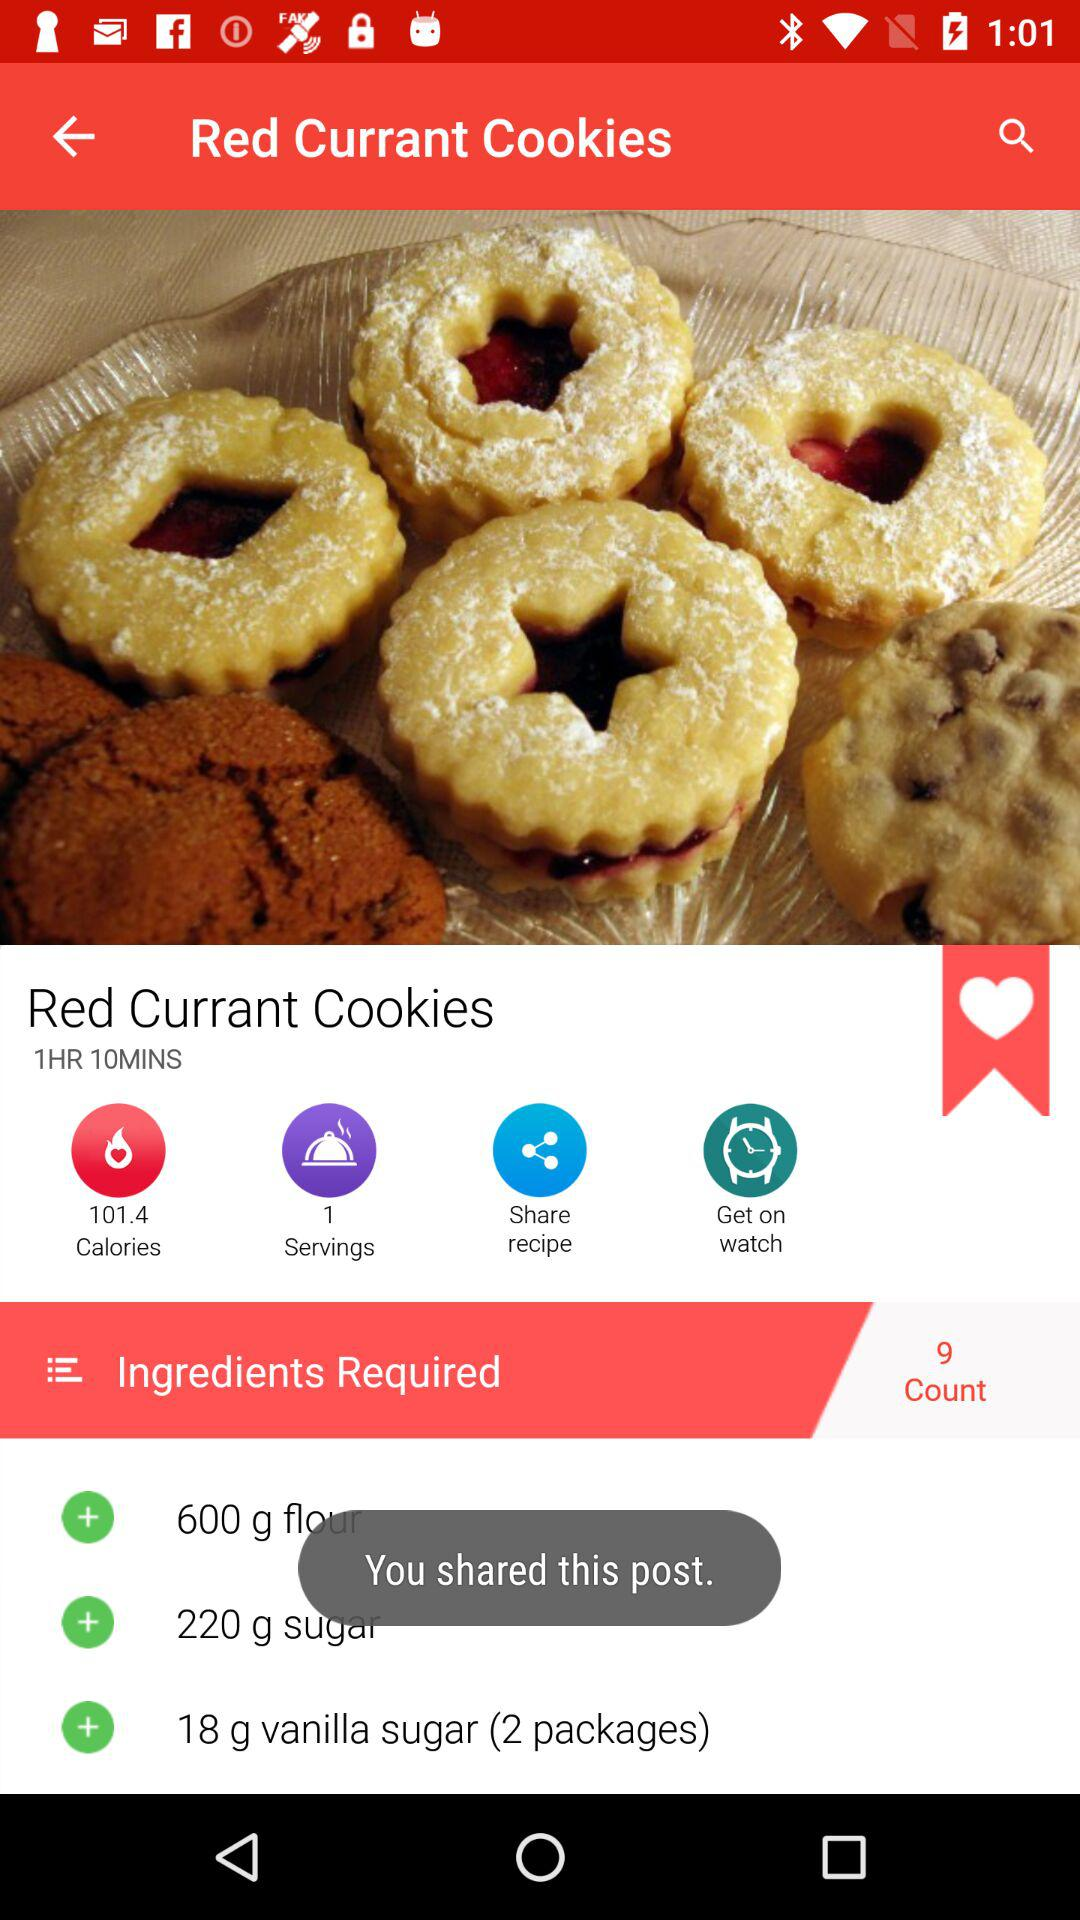How many servings does this recipe make?
Answer the question using a single word or phrase. 1 